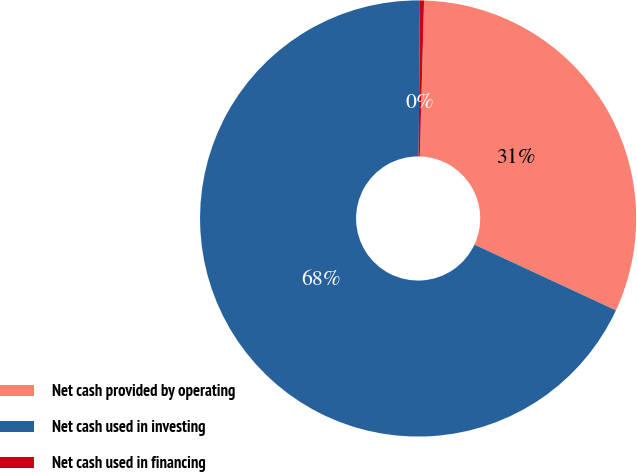Convert chart. <chart><loc_0><loc_0><loc_500><loc_500><pie_chart><fcel>Net cash provided by operating<fcel>Net cash used in investing<fcel>Net cash used in financing<nl><fcel>31.49%<fcel>68.21%<fcel>0.3%<nl></chart> 